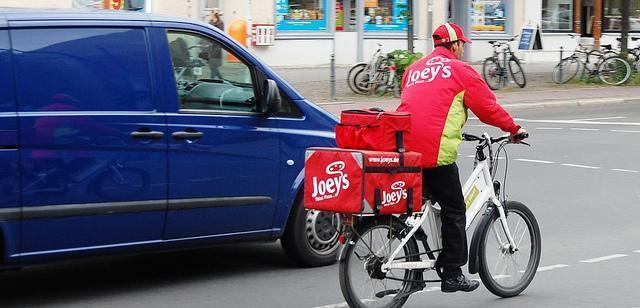How many cars are visible?
Give a very brief answer. 1. How many elephants are there?
Give a very brief answer. 0. 